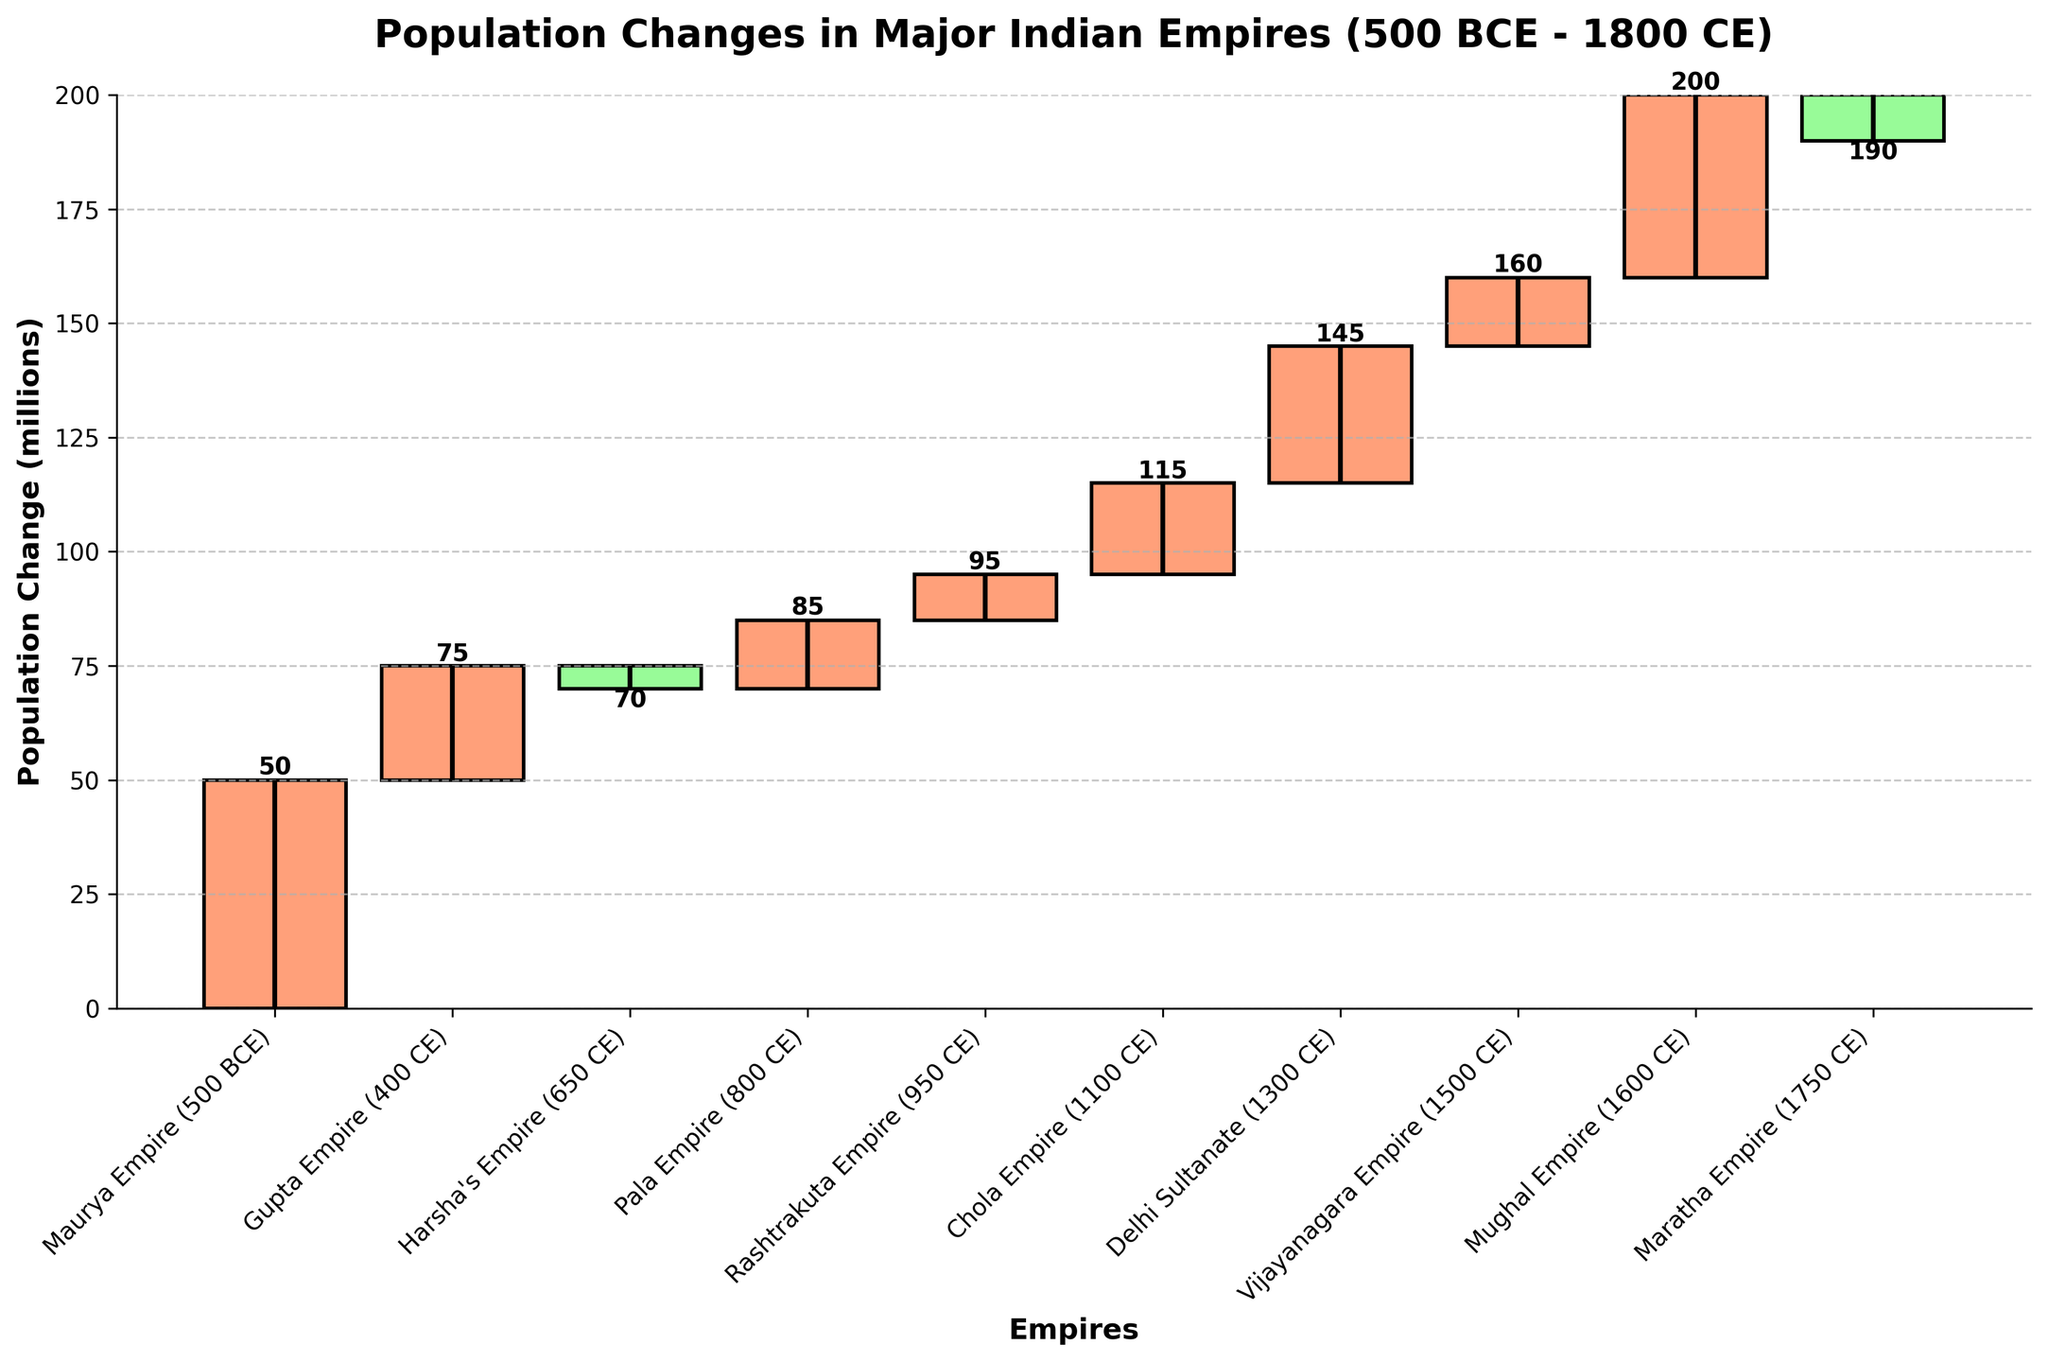What's the title of the waterfall chart? The title is displayed at the top of the chart, reading "Population Changes in Major Indian Empires (500 BCE - 1800 CE)".
Answer: Population Changes in Major Indian Empires (500 BCE - 1800 CE) What are the color codes used for positive and negative population changes? The positive changes are represented in a salmon color, while the negative changes are represented in a light green color.
Answer: Salmon and light green Which empire had the highest population increase? The bar representing the Mughal Empire (1600 CE) shows the highest positive change, around 40 million.
Answer: Mughal Empire Which empires experienced a population decrease? The bars for Harsha's Empire (650 CE) and Maratha Empire (1750 CE) are colored light green, indicating a population decrease.
Answer: Harsha's Empire and Maratha Empire What was the cumulative population change after the Gupta Empire? After the Maurya Empire added 50 million and the Gupta Empire added 25 million, the total cumulative change is 75 million.
Answer: 75 million How does the population change of the Rashtrakuta Empire compare to the Chola Empire? The Rashtrakuta Empire shows a population increase of 10 million, whereas the Chola Empire shows a larger increase of 20 million.
Answer: The Chola Empire had a higher increase Calculate the total population change from the Maurya Empire to the Mughal Empire. Sum all the changes from the Maurya Empire (50) to the Mughal Empire (40): \(50 + 25 - 5 + 15 + 10 + 20 + 30 + 15 + 40 = 200\).
Answer: 200 million What's the cumulative population change by the end of the Maratha Empire? Starting from 0, cumulatively add each change up to the Maratha Empire: \(50 + 25 - 5 + 15 + 10 + 20 + 30 + 15 + 40 - 10 = 190\).
Answer: 190 million Which period had the largest drop in population, and by how much? The largest drop is shown by the Maratha Empire (1750 CE), with a -10 million population change.
Answer: Maratha Empire, -10 million What is the average population change across all empires? Sum all the changes \(50 + 25 - 5 + 15 + 10 + 20 + 30 + 15 + 40 - 10 = 190\) and divide by the number of empires (10). \(190 / 10 = 19\).
Answer: 19 million 